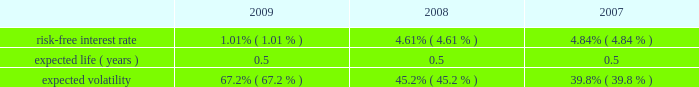Abiomed , inc .
And subsidiaries notes to consolidated financial statements 2014 ( continued ) note 12 .
Stock award plans and stock based compensation ( continued ) compensation expense recognized related to the company 2019s espp was approximately $ 0.1 million for each of the years ended march 31 , 2009 , 2008 and 2007 respectively .
The fair value of shares issued under the employee stock purchase plan was estimated on the commencement date of each offering period using the black-scholes option-pricing model with the following assumptions: .
Note 13 .
Capital stock in august 2008 , the company issued 2419932 shares of its common stock at a price of $ 17.3788 in a public offering , which resulted in net proceeds to the company of approximately $ 42.0 million , after deducting offering expenses .
In march 2007 , the company issued 5000000 shares of common stock in a public offering , and in april 2007 , an additional 80068 shares of common stock were issued in connection with the offering upon the partial exercise of the underwriters 2019 over-allotment option .
The company has authorized 1000000 shares of class b preferred stock , $ 0.01 par value , of which the board of directors can set the designation , rights and privileges .
No shares of class b preferred stock have been issued or are outstanding .
Note 14 .
Income taxes deferred tax assets and liabilities are recognized for the estimated future tax consequences attributable to tax benefit carryforwards and to differences between the financial statement amounts of assets and liabilities and their respective tax basis .
Deferred tax assets and liabilities are measured using enacted tax rates .
A valuation reserve is established if it is more likely than not that all or a portion of the deferred tax asset will not be realized .
The tax benefit associated with the stock option compensation deductions will be credited to equity when realized .
At march 31 , 2009 , the company had federal and state net operating loss carryforwards , or nols , of approximately $ 145.1 million and $ 97.1 million , respectively , which begin to expire in fiscal 2010 .
Additionally , at march 31 , 2009 , the company had federal and state research and development credit carryforwards of approximately $ 8.1 million and $ 4.2 million , respectively , which begin to expire in fiscal 2010 .
The company acquired impella , a german-based company , in may 2005 .
Impella had pre-acquisition net operating losses of approximately $ 18.2 million at the time of acquisition ( which is denominated in euros and is subject to foreign exchange remeasurement at each balance sheet date presented ) , and has since incurred net operating losses in each fiscal year since the acquisition .
During fiscal 2008 , the company determined that approximately $ 1.2 million of pre-acquisition operating losses could not be utilized .
The utilization of pre-acquisition net operating losses of impella in future periods is subject to certain statutory approvals and business requirements .
Due to uncertainties surrounding the company 2019s ability to generate future taxable income to realize these assets , a full valuation allowance has been established to offset the company 2019s net deferred tax assets and liabilities .
Additionally , the future utilization of the company 2019s nol and research and development credit carry forwards to offset future taxable income may be subject to a substantial annual limitation under section 382 of the internal revenue code due to ownership changes that have occurred previously or that could occur in the future .
Ownership changes , as defined in section 382 of the internal revenue code , can limit the amount of net operating loss carry forwards and research and development credit carry forwards that a company can use each year to offset future taxable income and taxes payable .
The company believes that all of its federal and state nol 2019s will be available for carryforward to future tax periods , subject to the statutory maximum carryforward limitation of any annual nol .
Any future potential limitation to all or a portion of the nol or research and development credit carry forwards , before they can be utilized , would reduce the company 2019s gross deferred tax assets .
The company will monitor subsequent ownership changes , which could impose limitations in the future. .
What was the range of volatility ( % (  % ) ) in the black scholes calculation for the three year period?\\n? 
Computations: subtract(table_max(expected volatility, none), table_min(expected volatility, none))
Answer: 0.274. 